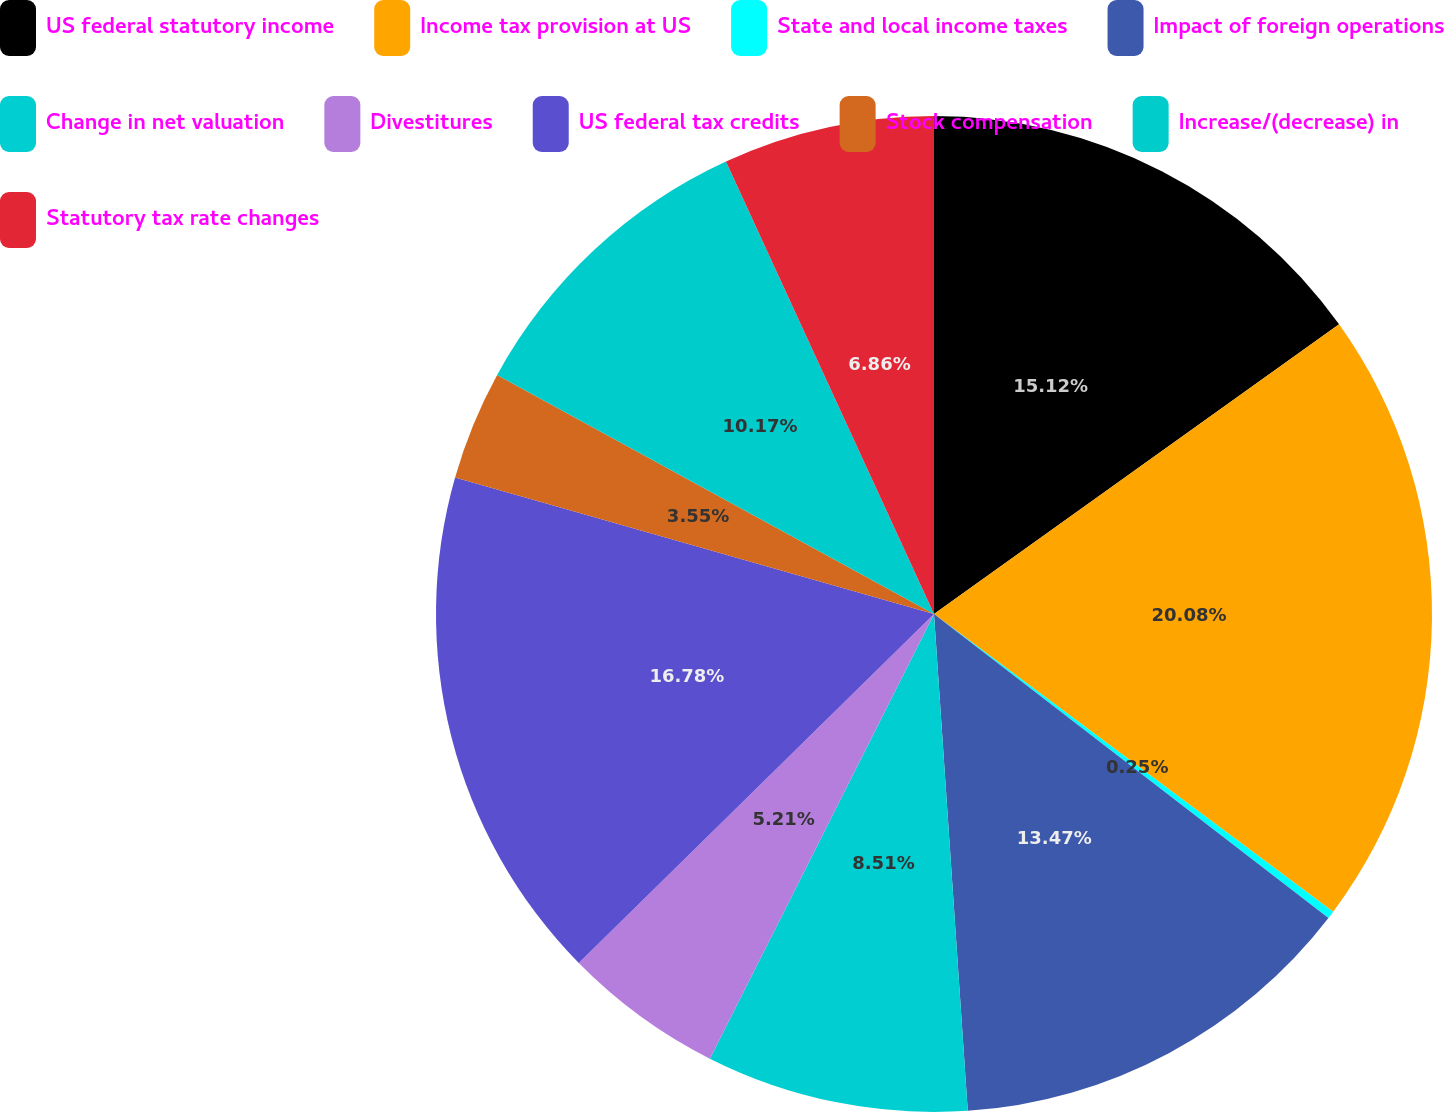Convert chart. <chart><loc_0><loc_0><loc_500><loc_500><pie_chart><fcel>US federal statutory income<fcel>Income tax provision at US<fcel>State and local income taxes<fcel>Impact of foreign operations<fcel>Change in net valuation<fcel>Divestitures<fcel>US federal tax credits<fcel>Stock compensation<fcel>Increase/(decrease) in<fcel>Statutory tax rate changes<nl><fcel>15.12%<fcel>20.08%<fcel>0.25%<fcel>13.47%<fcel>8.51%<fcel>5.21%<fcel>16.78%<fcel>3.55%<fcel>10.17%<fcel>6.86%<nl></chart> 